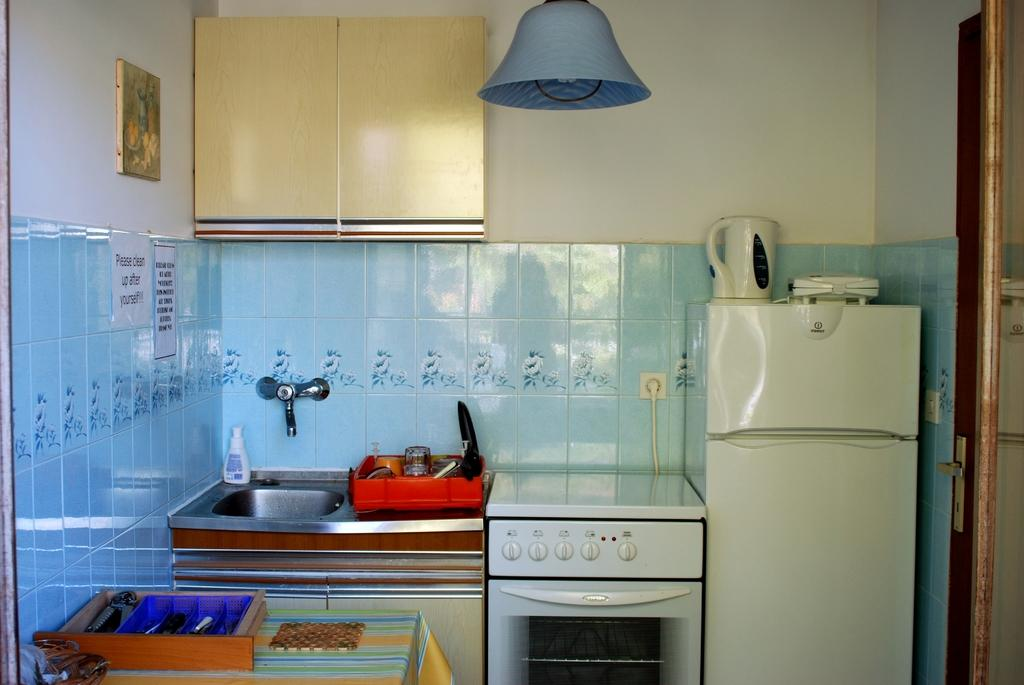<image>
Summarize the visual content of the image. a kitchen that has a sign asking to clean up after yourself 